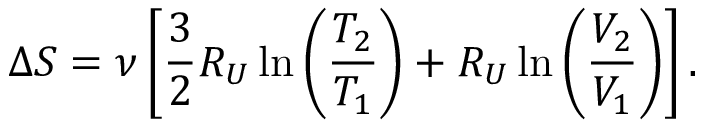Convert formula to latex. <formula><loc_0><loc_0><loc_500><loc_500>\Delta S = \nu \left [ \frac { 3 } { 2 } R _ { U } \ln \left ( \frac { T _ { 2 } } { T _ { 1 } } \right ) + R _ { U } \ln \left ( \frac { V _ { 2 } } { V _ { 1 } } \right ) \right ] .</formula> 